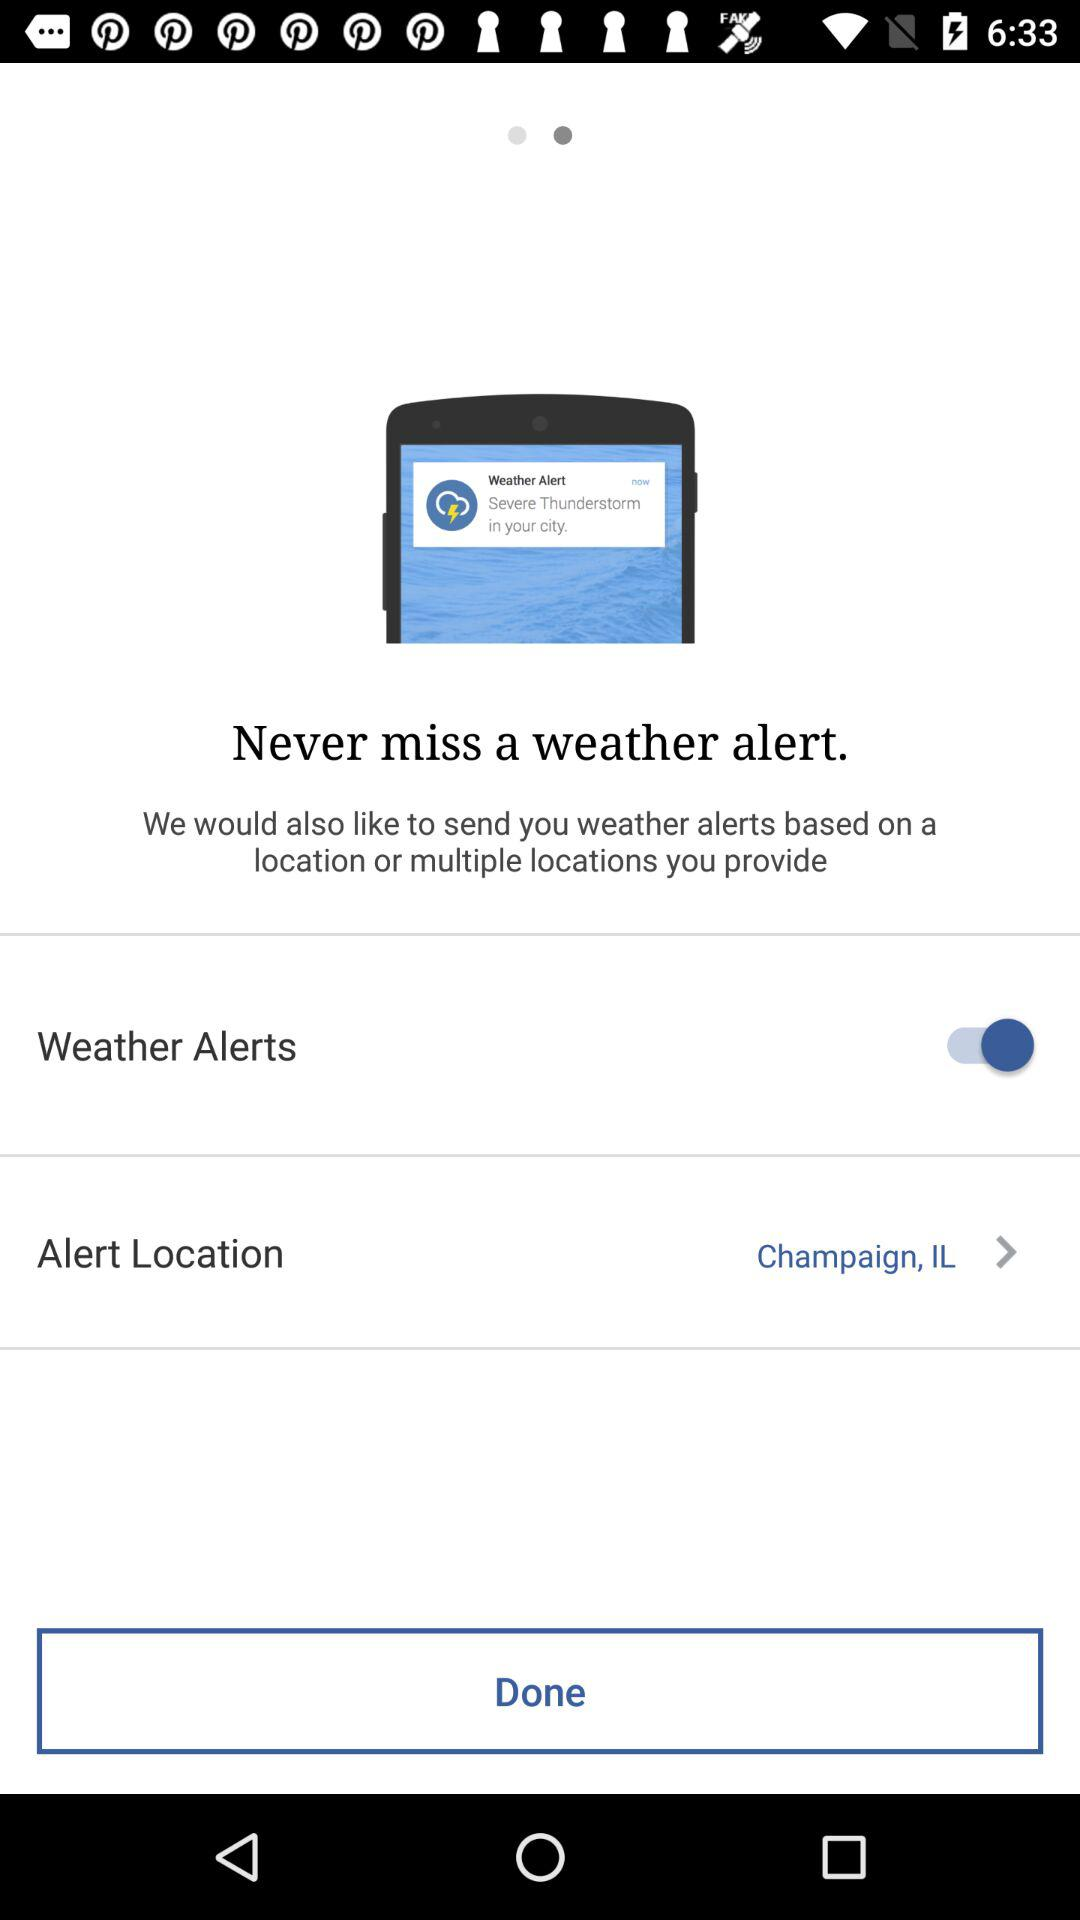What is the status of "Weather Alerts"? The status of "Weather Alerts" is "on". 